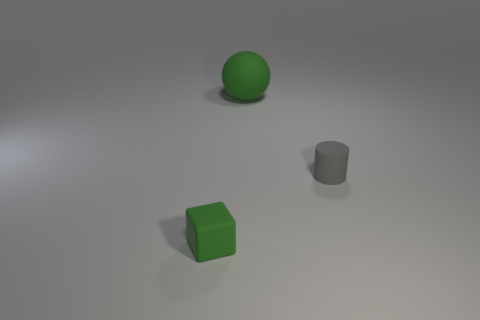Are there any large objects that have the same shape as the tiny green object?
Offer a very short reply. No. What size is the rubber thing that is left of the green object on the right side of the green thing to the left of the rubber ball?
Offer a terse response. Small. Are there the same number of tiny rubber things that are right of the green ball and big green rubber objects that are right of the tiny gray rubber cylinder?
Offer a terse response. No. There is a green cube that is the same material as the big sphere; what size is it?
Give a very brief answer. Small. What color is the small matte cylinder?
Make the answer very short. Gray. How many matte spheres are the same color as the cube?
Provide a short and direct response. 1. Are there any rubber balls to the right of the matte thing on the right side of the ball?
Offer a very short reply. No. How many other things are the same color as the small block?
Provide a short and direct response. 1. What is the size of the cube?
Offer a terse response. Small. Is there a cylinder?
Offer a terse response. Yes. 